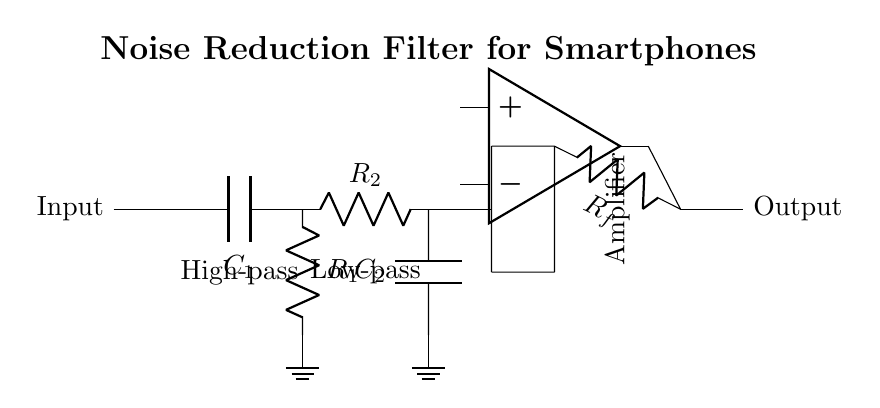What type of filter is shown in this circuit? The circuit diagram indicates a noise reduction filter, which is specifically designed to filter out unwanted noise in smartphone audio calls.
Answer: Noise reduction filter What components make up the high-pass filter stage? The high-pass filter stage consists of a capacitor labeled C1 and a resistor labeled R1, allowing higher frequency signals to pass while attenuating lower frequencies.
Answer: C1 and R1 What is the function of the amplifier in this circuit? The amplifier stage boosts the signal strength after it has been filtered by the high and low-pass filters, enhancing the overall call quality by increasing the audio signal level.
Answer: Boosting signal strength Which component is used for low-pass filtering in the circuit? The low-pass filter stage includes a resistor labeled R2 and a capacitor labeled C2, which together allow low-frequency signals to pass while filtering out high-frequency noise.
Answer: R2 and C2 What does the feedback resistor Rf accomplish in the circuit? The feedback resistor Rf alters the gain of the amplifier, which affects the output signal level, ensuring that it is appropriately amplified after filtering.
Answer: Alters gain of amplifier What type of current flows through this filter circuit? The filter circuit processes alternating current (AC) signals, as it is designed to filter audio frequencies from voice calls on smartphones.
Answer: Alternating current 